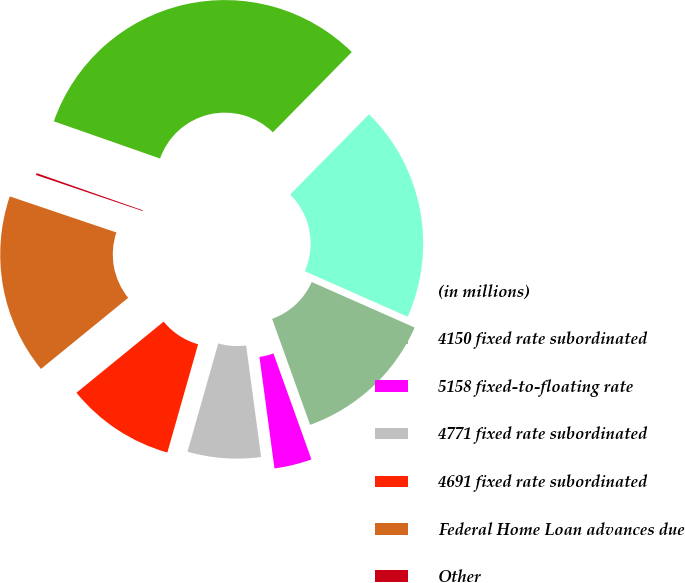Convert chart. <chart><loc_0><loc_0><loc_500><loc_500><pie_chart><fcel>(in millions)<fcel>4150 fixed rate subordinated<fcel>5158 fixed-to-floating rate<fcel>4771 fixed rate subordinated<fcel>4691 fixed rate subordinated<fcel>Federal Home Loan advances due<fcel>Other<fcel>Total long-term borrowed funds<nl><fcel>19.26%<fcel>12.9%<fcel>3.35%<fcel>6.53%<fcel>9.71%<fcel>16.08%<fcel>0.17%<fcel>32.0%<nl></chart> 